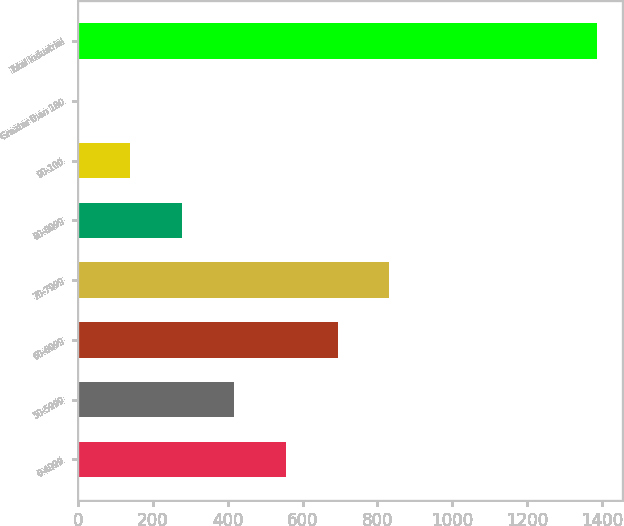Convert chart to OTSL. <chart><loc_0><loc_0><loc_500><loc_500><bar_chart><fcel>0-4999<fcel>50-5999<fcel>60-6999<fcel>70-7999<fcel>80-8999<fcel>90-100<fcel>Greater than 100<fcel>Total Industrial<nl><fcel>555.12<fcel>416.81<fcel>693.44<fcel>831.76<fcel>278.49<fcel>140.17<fcel>1.85<fcel>1385<nl></chart> 